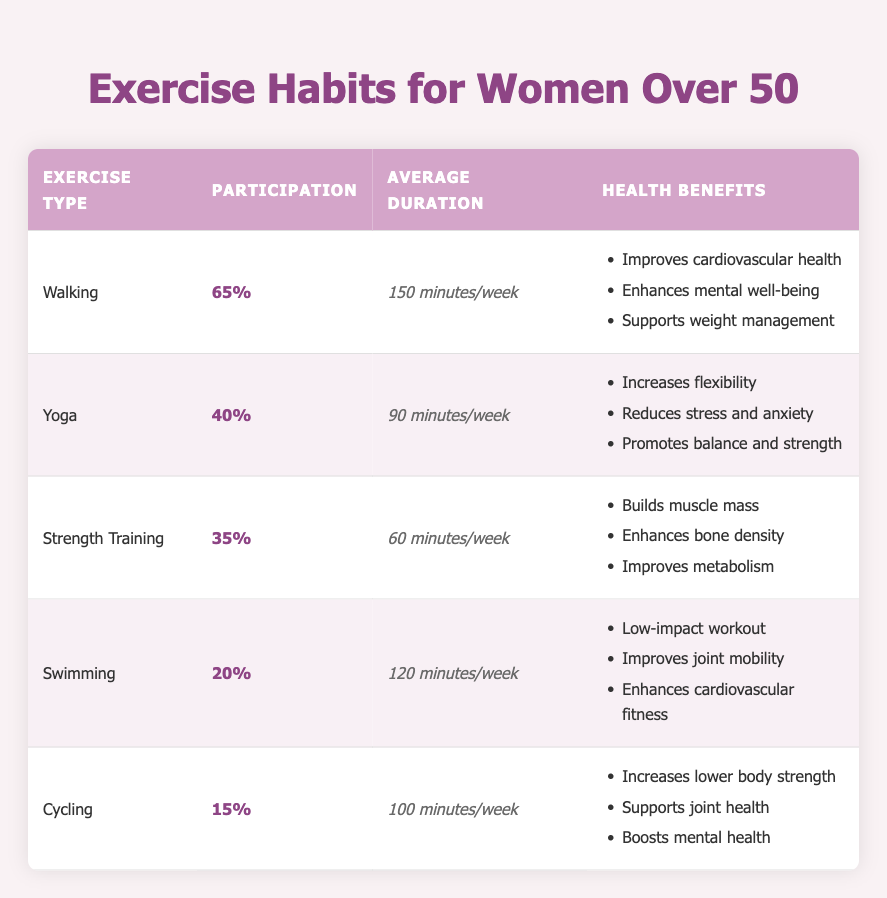What is the most popular exercise among women aged 50 and above? The table shows participation percentages for each exercise type. Walking has the highest percentage of participation at 65%, making it the most popular exercise.
Answer: Walking How many minutes per week do women aged 50 and above average for Strength Training? The table indicates that women average 60 minutes per week for Strength Training, directly listed in the average duration column.
Answer: 60 minutes Which exercise has the lowest participation among women over 50? Examining the participation percentages, Cycling has the lowest participation at 15%, indicating it is the least popular exercise type among the surveyed group.
Answer: Cycling What is the average participation percentage of all exercises listed? The participation percentages are 65%, 40%, 35%, 20%, and 15%. Adding these gives a total of 175%. Dividing by the number of exercises (5) results in an average participation percentage of 35%.
Answer: 35% Is it true that Swimming includes benefits for joint mobility? Yes, the table lists "Improves joint mobility" as one of the health benefits of Swimming, confirming that this exercise indeed offers that benefit.
Answer: Yes Which exercise type has more average duration per week: Swimming or Yoga? Swimming averages 120 minutes per week, while Yoga averages 90 minutes per week. Since 120 is greater than 90, Swimming has a longer average duration.
Answer: Swimming How many exercises have a participation rate of 35% or higher? The exercises with participation rates of 35% or higher are Walking (65%), Yoga (40%), and Strength Training (35%). There are three exercises in total that meet this criterion.
Answer: Three What health benefit is unique to Strength Training that is not mentioned for other exercises? The health benefit "Enhances bone density" is listed for Strength Training but does not appear in the health benefits for Walking, Yoga, Swimming, or Cycling, making it unique to Strength Training.
Answer: Enhances bone density Which exercise type offers the highest average duration per week alongside health benefits that reduce stress? Swimming offers an average of 120 minutes per week along with health benefits such as “Improves joint mobility” and does not mention stress reduction. The exercise that provides both high duration (90 minutes) and includes stress reduction is Yoga.
Answer: Yoga 